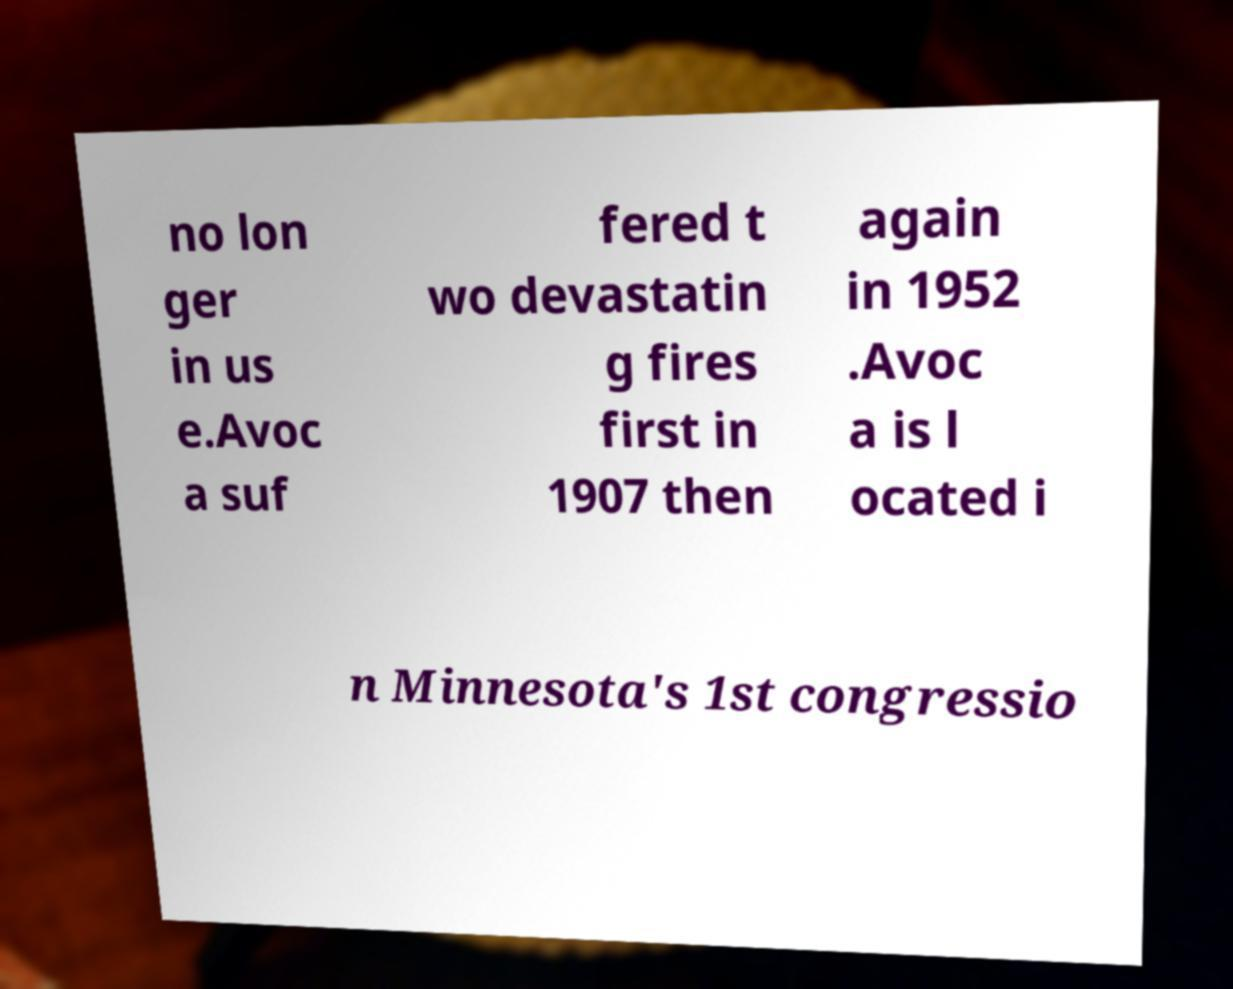I need the written content from this picture converted into text. Can you do that? no lon ger in us e.Avoc a suf fered t wo devastatin g fires first in 1907 then again in 1952 .Avoc a is l ocated i n Minnesota's 1st congressio 